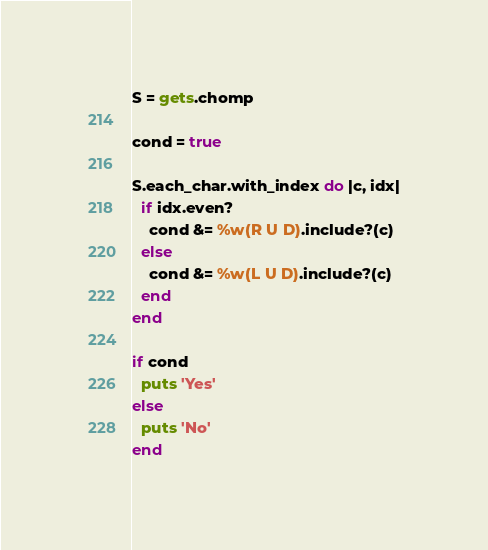Convert code to text. <code><loc_0><loc_0><loc_500><loc_500><_Ruby_>S = gets.chomp

cond = true

S.each_char.with_index do |c, idx|
  if idx.even?
    cond &= %w(R U D).include?(c)
  else
    cond &= %w(L U D).include?(c)
  end
end

if cond
  puts 'Yes'
else
  puts 'No'
end
</code> 